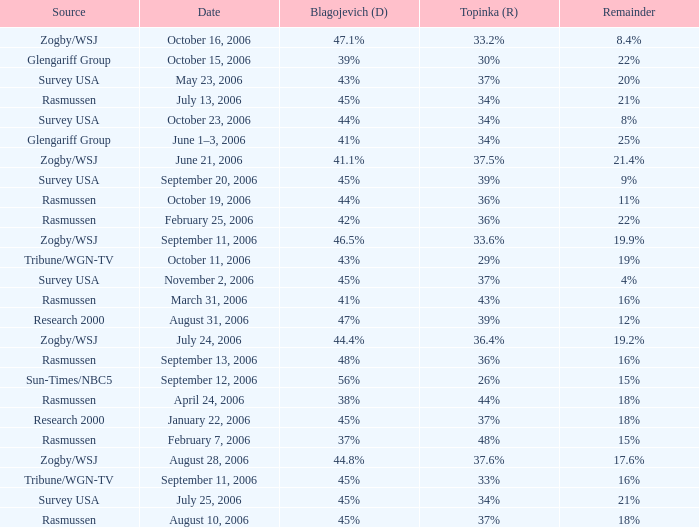Which Blagojevich (D) happened on october 16, 2006? 47.1%. 